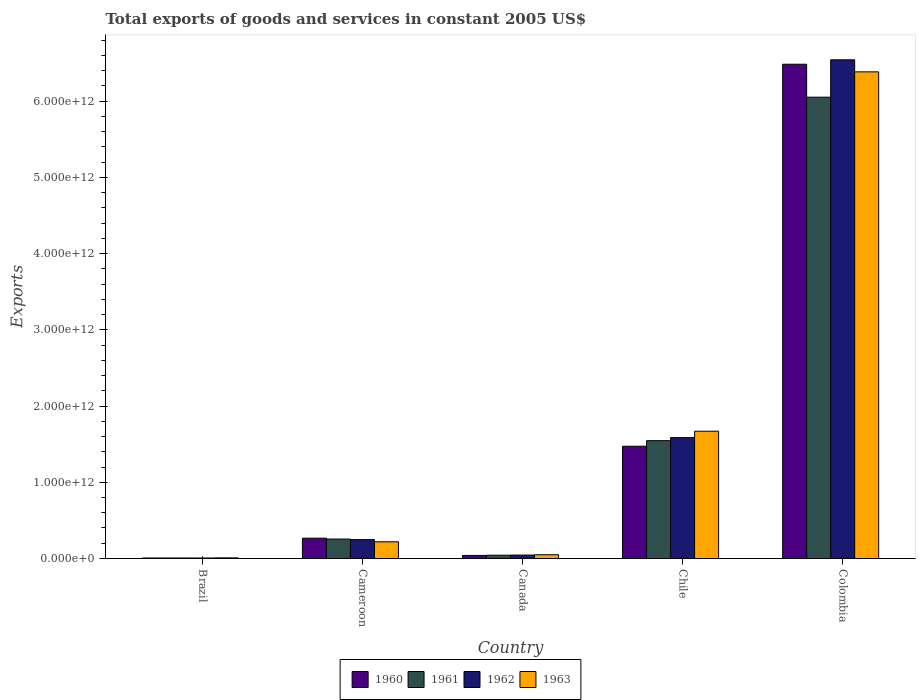How many different coloured bars are there?
Keep it short and to the point. 4. Are the number of bars per tick equal to the number of legend labels?
Ensure brevity in your answer.  Yes. How many bars are there on the 1st tick from the left?
Ensure brevity in your answer.  4. What is the label of the 4th group of bars from the left?
Provide a succinct answer. Chile. What is the total exports of goods and services in 1963 in Canada?
Make the answer very short. 4.91e+1. Across all countries, what is the maximum total exports of goods and services in 1962?
Give a very brief answer. 6.54e+12. Across all countries, what is the minimum total exports of goods and services in 1960?
Provide a short and direct response. 6.63e+09. In which country was the total exports of goods and services in 1963 minimum?
Keep it short and to the point. Brazil. What is the total total exports of goods and services in 1961 in the graph?
Give a very brief answer. 7.90e+12. What is the difference between the total exports of goods and services in 1960 in Cameroon and that in Chile?
Your answer should be compact. -1.21e+12. What is the difference between the total exports of goods and services in 1960 in Brazil and the total exports of goods and services in 1963 in Cameroon?
Provide a short and direct response. -2.12e+11. What is the average total exports of goods and services in 1963 per country?
Your answer should be compact. 1.67e+12. What is the difference between the total exports of goods and services of/in 1962 and total exports of goods and services of/in 1960 in Brazil?
Provide a succinct answer. -1.72e+08. In how many countries, is the total exports of goods and services in 1962 greater than 4000000000000 US$?
Keep it short and to the point. 1. What is the ratio of the total exports of goods and services in 1961 in Brazil to that in Chile?
Offer a terse response. 0. Is the total exports of goods and services in 1960 in Brazil less than that in Canada?
Keep it short and to the point. Yes. What is the difference between the highest and the second highest total exports of goods and services in 1962?
Provide a short and direct response. -6.29e+12. What is the difference between the highest and the lowest total exports of goods and services in 1963?
Offer a very short reply. 6.38e+12. In how many countries, is the total exports of goods and services in 1962 greater than the average total exports of goods and services in 1962 taken over all countries?
Your response must be concise. 1. Is it the case that in every country, the sum of the total exports of goods and services in 1962 and total exports of goods and services in 1963 is greater than the sum of total exports of goods and services in 1960 and total exports of goods and services in 1961?
Offer a very short reply. No. Is it the case that in every country, the sum of the total exports of goods and services in 1960 and total exports of goods and services in 1961 is greater than the total exports of goods and services in 1963?
Your answer should be very brief. Yes. How many bars are there?
Provide a succinct answer. 20. What is the difference between two consecutive major ticks on the Y-axis?
Your response must be concise. 1.00e+12. Are the values on the major ticks of Y-axis written in scientific E-notation?
Ensure brevity in your answer.  Yes. Does the graph contain grids?
Your answer should be compact. No. How many legend labels are there?
Keep it short and to the point. 4. How are the legend labels stacked?
Ensure brevity in your answer.  Horizontal. What is the title of the graph?
Offer a very short reply. Total exports of goods and services in constant 2005 US$. Does "1983" appear as one of the legend labels in the graph?
Your response must be concise. No. What is the label or title of the Y-axis?
Your answer should be very brief. Exports. What is the Exports of 1960 in Brazil?
Give a very brief answer. 6.63e+09. What is the Exports in 1961 in Brazil?
Offer a terse response. 6.97e+09. What is the Exports in 1962 in Brazil?
Offer a terse response. 6.46e+09. What is the Exports of 1963 in Brazil?
Offer a very short reply. 8.26e+09. What is the Exports of 1960 in Cameroon?
Give a very brief answer. 2.66e+11. What is the Exports of 1961 in Cameroon?
Offer a terse response. 2.55e+11. What is the Exports in 1962 in Cameroon?
Provide a succinct answer. 2.48e+11. What is the Exports of 1963 in Cameroon?
Offer a terse response. 2.19e+11. What is the Exports of 1960 in Canada?
Your response must be concise. 4.02e+1. What is the Exports of 1961 in Canada?
Give a very brief answer. 4.29e+1. What is the Exports of 1962 in Canada?
Make the answer very short. 4.49e+1. What is the Exports of 1963 in Canada?
Your answer should be very brief. 4.91e+1. What is the Exports in 1960 in Chile?
Make the answer very short. 1.47e+12. What is the Exports in 1961 in Chile?
Give a very brief answer. 1.55e+12. What is the Exports of 1962 in Chile?
Your response must be concise. 1.59e+12. What is the Exports in 1963 in Chile?
Provide a succinct answer. 1.67e+12. What is the Exports of 1960 in Colombia?
Offer a very short reply. 6.48e+12. What is the Exports in 1961 in Colombia?
Give a very brief answer. 6.05e+12. What is the Exports of 1962 in Colombia?
Offer a terse response. 6.54e+12. What is the Exports of 1963 in Colombia?
Provide a succinct answer. 6.38e+12. Across all countries, what is the maximum Exports in 1960?
Keep it short and to the point. 6.48e+12. Across all countries, what is the maximum Exports in 1961?
Your answer should be very brief. 6.05e+12. Across all countries, what is the maximum Exports in 1962?
Give a very brief answer. 6.54e+12. Across all countries, what is the maximum Exports of 1963?
Offer a terse response. 6.38e+12. Across all countries, what is the minimum Exports of 1960?
Your response must be concise. 6.63e+09. Across all countries, what is the minimum Exports of 1961?
Offer a terse response. 6.97e+09. Across all countries, what is the minimum Exports in 1962?
Your answer should be very brief. 6.46e+09. Across all countries, what is the minimum Exports of 1963?
Make the answer very short. 8.26e+09. What is the total Exports in 1960 in the graph?
Give a very brief answer. 8.27e+12. What is the total Exports of 1961 in the graph?
Your answer should be compact. 7.90e+12. What is the total Exports in 1962 in the graph?
Offer a terse response. 8.43e+12. What is the total Exports in 1963 in the graph?
Ensure brevity in your answer.  8.33e+12. What is the difference between the Exports in 1960 in Brazil and that in Cameroon?
Give a very brief answer. -2.60e+11. What is the difference between the Exports of 1961 in Brazil and that in Cameroon?
Offer a very short reply. -2.48e+11. What is the difference between the Exports in 1962 in Brazil and that in Cameroon?
Give a very brief answer. -2.41e+11. What is the difference between the Exports in 1963 in Brazil and that in Cameroon?
Offer a very short reply. -2.11e+11. What is the difference between the Exports of 1960 in Brazil and that in Canada?
Your response must be concise. -3.36e+1. What is the difference between the Exports of 1961 in Brazil and that in Canada?
Give a very brief answer. -3.60e+1. What is the difference between the Exports in 1962 in Brazil and that in Canada?
Provide a succinct answer. -3.85e+1. What is the difference between the Exports in 1963 in Brazil and that in Canada?
Make the answer very short. -4.08e+1. What is the difference between the Exports in 1960 in Brazil and that in Chile?
Make the answer very short. -1.47e+12. What is the difference between the Exports of 1961 in Brazil and that in Chile?
Offer a very short reply. -1.54e+12. What is the difference between the Exports of 1962 in Brazil and that in Chile?
Give a very brief answer. -1.58e+12. What is the difference between the Exports in 1963 in Brazil and that in Chile?
Ensure brevity in your answer.  -1.66e+12. What is the difference between the Exports of 1960 in Brazil and that in Colombia?
Give a very brief answer. -6.48e+12. What is the difference between the Exports of 1961 in Brazil and that in Colombia?
Keep it short and to the point. -6.04e+12. What is the difference between the Exports in 1962 in Brazil and that in Colombia?
Make the answer very short. -6.54e+12. What is the difference between the Exports in 1963 in Brazil and that in Colombia?
Ensure brevity in your answer.  -6.38e+12. What is the difference between the Exports of 1960 in Cameroon and that in Canada?
Make the answer very short. 2.26e+11. What is the difference between the Exports of 1961 in Cameroon and that in Canada?
Your answer should be very brief. 2.12e+11. What is the difference between the Exports in 1962 in Cameroon and that in Canada?
Make the answer very short. 2.03e+11. What is the difference between the Exports in 1963 in Cameroon and that in Canada?
Keep it short and to the point. 1.70e+11. What is the difference between the Exports in 1960 in Cameroon and that in Chile?
Ensure brevity in your answer.  -1.21e+12. What is the difference between the Exports in 1961 in Cameroon and that in Chile?
Your response must be concise. -1.29e+12. What is the difference between the Exports of 1962 in Cameroon and that in Chile?
Provide a short and direct response. -1.34e+12. What is the difference between the Exports of 1963 in Cameroon and that in Chile?
Offer a terse response. -1.45e+12. What is the difference between the Exports in 1960 in Cameroon and that in Colombia?
Offer a terse response. -6.22e+12. What is the difference between the Exports in 1961 in Cameroon and that in Colombia?
Your response must be concise. -5.80e+12. What is the difference between the Exports in 1962 in Cameroon and that in Colombia?
Give a very brief answer. -6.29e+12. What is the difference between the Exports of 1963 in Cameroon and that in Colombia?
Keep it short and to the point. -6.17e+12. What is the difference between the Exports in 1960 in Canada and that in Chile?
Offer a terse response. -1.43e+12. What is the difference between the Exports of 1961 in Canada and that in Chile?
Offer a terse response. -1.50e+12. What is the difference between the Exports of 1962 in Canada and that in Chile?
Keep it short and to the point. -1.54e+12. What is the difference between the Exports of 1963 in Canada and that in Chile?
Your response must be concise. -1.62e+12. What is the difference between the Exports in 1960 in Canada and that in Colombia?
Offer a very short reply. -6.44e+12. What is the difference between the Exports in 1961 in Canada and that in Colombia?
Offer a terse response. -6.01e+12. What is the difference between the Exports in 1962 in Canada and that in Colombia?
Keep it short and to the point. -6.50e+12. What is the difference between the Exports of 1963 in Canada and that in Colombia?
Your answer should be compact. -6.34e+12. What is the difference between the Exports of 1960 in Chile and that in Colombia?
Your answer should be compact. -5.01e+12. What is the difference between the Exports of 1961 in Chile and that in Colombia?
Your response must be concise. -4.51e+12. What is the difference between the Exports in 1962 in Chile and that in Colombia?
Provide a short and direct response. -4.96e+12. What is the difference between the Exports of 1963 in Chile and that in Colombia?
Ensure brevity in your answer.  -4.71e+12. What is the difference between the Exports of 1960 in Brazil and the Exports of 1961 in Cameroon?
Provide a short and direct response. -2.48e+11. What is the difference between the Exports of 1960 in Brazil and the Exports of 1962 in Cameroon?
Offer a terse response. -2.41e+11. What is the difference between the Exports in 1960 in Brazil and the Exports in 1963 in Cameroon?
Offer a very short reply. -2.12e+11. What is the difference between the Exports in 1961 in Brazil and the Exports in 1962 in Cameroon?
Offer a very short reply. -2.41e+11. What is the difference between the Exports of 1961 in Brazil and the Exports of 1963 in Cameroon?
Keep it short and to the point. -2.12e+11. What is the difference between the Exports of 1962 in Brazil and the Exports of 1963 in Cameroon?
Keep it short and to the point. -2.13e+11. What is the difference between the Exports of 1960 in Brazil and the Exports of 1961 in Canada?
Ensure brevity in your answer.  -3.63e+1. What is the difference between the Exports in 1960 in Brazil and the Exports in 1962 in Canada?
Your response must be concise. -3.83e+1. What is the difference between the Exports in 1960 in Brazil and the Exports in 1963 in Canada?
Your answer should be very brief. -4.24e+1. What is the difference between the Exports in 1961 in Brazil and the Exports in 1962 in Canada?
Keep it short and to the point. -3.79e+1. What is the difference between the Exports of 1961 in Brazil and the Exports of 1963 in Canada?
Provide a succinct answer. -4.21e+1. What is the difference between the Exports of 1962 in Brazil and the Exports of 1963 in Canada?
Keep it short and to the point. -4.26e+1. What is the difference between the Exports in 1960 in Brazil and the Exports in 1961 in Chile?
Offer a very short reply. -1.54e+12. What is the difference between the Exports in 1960 in Brazil and the Exports in 1962 in Chile?
Keep it short and to the point. -1.58e+12. What is the difference between the Exports in 1960 in Brazil and the Exports in 1963 in Chile?
Offer a very short reply. -1.66e+12. What is the difference between the Exports in 1961 in Brazil and the Exports in 1962 in Chile?
Offer a terse response. -1.58e+12. What is the difference between the Exports in 1961 in Brazil and the Exports in 1963 in Chile?
Keep it short and to the point. -1.66e+12. What is the difference between the Exports in 1962 in Brazil and the Exports in 1963 in Chile?
Your response must be concise. -1.66e+12. What is the difference between the Exports in 1960 in Brazil and the Exports in 1961 in Colombia?
Your response must be concise. -6.05e+12. What is the difference between the Exports in 1960 in Brazil and the Exports in 1962 in Colombia?
Offer a very short reply. -6.54e+12. What is the difference between the Exports in 1960 in Brazil and the Exports in 1963 in Colombia?
Provide a short and direct response. -6.38e+12. What is the difference between the Exports of 1961 in Brazil and the Exports of 1962 in Colombia?
Your response must be concise. -6.54e+12. What is the difference between the Exports in 1961 in Brazil and the Exports in 1963 in Colombia?
Offer a terse response. -6.38e+12. What is the difference between the Exports of 1962 in Brazil and the Exports of 1963 in Colombia?
Your answer should be compact. -6.38e+12. What is the difference between the Exports in 1960 in Cameroon and the Exports in 1961 in Canada?
Ensure brevity in your answer.  2.24e+11. What is the difference between the Exports of 1960 in Cameroon and the Exports of 1962 in Canada?
Provide a succinct answer. 2.22e+11. What is the difference between the Exports of 1960 in Cameroon and the Exports of 1963 in Canada?
Offer a very short reply. 2.17e+11. What is the difference between the Exports of 1961 in Cameroon and the Exports of 1962 in Canada?
Your response must be concise. 2.10e+11. What is the difference between the Exports of 1961 in Cameroon and the Exports of 1963 in Canada?
Give a very brief answer. 2.06e+11. What is the difference between the Exports of 1962 in Cameroon and the Exports of 1963 in Canada?
Give a very brief answer. 1.99e+11. What is the difference between the Exports of 1960 in Cameroon and the Exports of 1961 in Chile?
Your answer should be compact. -1.28e+12. What is the difference between the Exports in 1960 in Cameroon and the Exports in 1962 in Chile?
Give a very brief answer. -1.32e+12. What is the difference between the Exports of 1960 in Cameroon and the Exports of 1963 in Chile?
Make the answer very short. -1.40e+12. What is the difference between the Exports in 1961 in Cameroon and the Exports in 1962 in Chile?
Offer a terse response. -1.33e+12. What is the difference between the Exports in 1961 in Cameroon and the Exports in 1963 in Chile?
Keep it short and to the point. -1.41e+12. What is the difference between the Exports of 1962 in Cameroon and the Exports of 1963 in Chile?
Your response must be concise. -1.42e+12. What is the difference between the Exports of 1960 in Cameroon and the Exports of 1961 in Colombia?
Give a very brief answer. -5.79e+12. What is the difference between the Exports in 1960 in Cameroon and the Exports in 1962 in Colombia?
Provide a succinct answer. -6.28e+12. What is the difference between the Exports in 1960 in Cameroon and the Exports in 1963 in Colombia?
Your answer should be very brief. -6.12e+12. What is the difference between the Exports in 1961 in Cameroon and the Exports in 1962 in Colombia?
Your answer should be compact. -6.29e+12. What is the difference between the Exports in 1961 in Cameroon and the Exports in 1963 in Colombia?
Ensure brevity in your answer.  -6.13e+12. What is the difference between the Exports in 1962 in Cameroon and the Exports in 1963 in Colombia?
Offer a terse response. -6.14e+12. What is the difference between the Exports in 1960 in Canada and the Exports in 1961 in Chile?
Provide a short and direct response. -1.51e+12. What is the difference between the Exports of 1960 in Canada and the Exports of 1962 in Chile?
Make the answer very short. -1.55e+12. What is the difference between the Exports in 1960 in Canada and the Exports in 1963 in Chile?
Your answer should be very brief. -1.63e+12. What is the difference between the Exports of 1961 in Canada and the Exports of 1962 in Chile?
Your answer should be compact. -1.54e+12. What is the difference between the Exports of 1961 in Canada and the Exports of 1963 in Chile?
Your answer should be compact. -1.63e+12. What is the difference between the Exports in 1962 in Canada and the Exports in 1963 in Chile?
Offer a terse response. -1.62e+12. What is the difference between the Exports of 1960 in Canada and the Exports of 1961 in Colombia?
Your response must be concise. -6.01e+12. What is the difference between the Exports in 1960 in Canada and the Exports in 1962 in Colombia?
Provide a succinct answer. -6.50e+12. What is the difference between the Exports of 1960 in Canada and the Exports of 1963 in Colombia?
Your response must be concise. -6.34e+12. What is the difference between the Exports in 1961 in Canada and the Exports in 1962 in Colombia?
Provide a succinct answer. -6.50e+12. What is the difference between the Exports in 1961 in Canada and the Exports in 1963 in Colombia?
Give a very brief answer. -6.34e+12. What is the difference between the Exports of 1962 in Canada and the Exports of 1963 in Colombia?
Your answer should be compact. -6.34e+12. What is the difference between the Exports of 1960 in Chile and the Exports of 1961 in Colombia?
Your response must be concise. -4.58e+12. What is the difference between the Exports of 1960 in Chile and the Exports of 1962 in Colombia?
Offer a terse response. -5.07e+12. What is the difference between the Exports of 1960 in Chile and the Exports of 1963 in Colombia?
Provide a short and direct response. -4.91e+12. What is the difference between the Exports in 1961 in Chile and the Exports in 1962 in Colombia?
Provide a succinct answer. -5.00e+12. What is the difference between the Exports in 1961 in Chile and the Exports in 1963 in Colombia?
Make the answer very short. -4.84e+12. What is the difference between the Exports in 1962 in Chile and the Exports in 1963 in Colombia?
Provide a short and direct response. -4.80e+12. What is the average Exports in 1960 per country?
Your response must be concise. 1.65e+12. What is the average Exports of 1961 per country?
Provide a short and direct response. 1.58e+12. What is the average Exports of 1962 per country?
Provide a succinct answer. 1.69e+12. What is the average Exports in 1963 per country?
Your answer should be very brief. 1.67e+12. What is the difference between the Exports of 1960 and Exports of 1961 in Brazil?
Ensure brevity in your answer.  -3.44e+08. What is the difference between the Exports in 1960 and Exports in 1962 in Brazil?
Offer a very short reply. 1.72e+08. What is the difference between the Exports in 1960 and Exports in 1963 in Brazil?
Keep it short and to the point. -1.64e+09. What is the difference between the Exports of 1961 and Exports of 1962 in Brazil?
Provide a short and direct response. 5.16e+08. What is the difference between the Exports of 1961 and Exports of 1963 in Brazil?
Offer a very short reply. -1.29e+09. What is the difference between the Exports of 1962 and Exports of 1963 in Brazil?
Your answer should be compact. -1.81e+09. What is the difference between the Exports in 1960 and Exports in 1961 in Cameroon?
Offer a very short reply. 1.14e+1. What is the difference between the Exports in 1960 and Exports in 1962 in Cameroon?
Your answer should be very brief. 1.88e+1. What is the difference between the Exports of 1960 and Exports of 1963 in Cameroon?
Provide a succinct answer. 4.75e+1. What is the difference between the Exports in 1961 and Exports in 1962 in Cameroon?
Ensure brevity in your answer.  7.43e+09. What is the difference between the Exports in 1961 and Exports in 1963 in Cameroon?
Make the answer very short. 3.61e+1. What is the difference between the Exports in 1962 and Exports in 1963 in Cameroon?
Make the answer very short. 2.87e+1. What is the difference between the Exports of 1960 and Exports of 1961 in Canada?
Provide a succinct answer. -2.73e+09. What is the difference between the Exports of 1960 and Exports of 1962 in Canada?
Make the answer very short. -4.72e+09. What is the difference between the Exports of 1960 and Exports of 1963 in Canada?
Provide a short and direct response. -8.86e+09. What is the difference between the Exports of 1961 and Exports of 1962 in Canada?
Ensure brevity in your answer.  -1.98e+09. What is the difference between the Exports in 1961 and Exports in 1963 in Canada?
Give a very brief answer. -6.12e+09. What is the difference between the Exports of 1962 and Exports of 1963 in Canada?
Offer a very short reply. -4.14e+09. What is the difference between the Exports of 1960 and Exports of 1961 in Chile?
Ensure brevity in your answer.  -7.28e+1. What is the difference between the Exports in 1960 and Exports in 1962 in Chile?
Make the answer very short. -1.13e+11. What is the difference between the Exports of 1960 and Exports of 1963 in Chile?
Offer a terse response. -1.97e+11. What is the difference between the Exports in 1961 and Exports in 1962 in Chile?
Give a very brief answer. -4.03e+1. What is the difference between the Exports in 1961 and Exports in 1963 in Chile?
Keep it short and to the point. -1.24e+11. What is the difference between the Exports of 1962 and Exports of 1963 in Chile?
Provide a succinct answer. -8.37e+1. What is the difference between the Exports in 1960 and Exports in 1961 in Colombia?
Your response must be concise. 4.32e+11. What is the difference between the Exports of 1960 and Exports of 1962 in Colombia?
Make the answer very short. -5.79e+1. What is the difference between the Exports in 1960 and Exports in 1963 in Colombia?
Make the answer very short. 1.00e+11. What is the difference between the Exports of 1961 and Exports of 1962 in Colombia?
Provide a succinct answer. -4.90e+11. What is the difference between the Exports of 1961 and Exports of 1963 in Colombia?
Provide a succinct answer. -3.32e+11. What is the difference between the Exports of 1962 and Exports of 1963 in Colombia?
Your answer should be compact. 1.58e+11. What is the ratio of the Exports of 1960 in Brazil to that in Cameroon?
Offer a very short reply. 0.02. What is the ratio of the Exports of 1961 in Brazil to that in Cameroon?
Your answer should be very brief. 0.03. What is the ratio of the Exports of 1962 in Brazil to that in Cameroon?
Provide a short and direct response. 0.03. What is the ratio of the Exports in 1963 in Brazil to that in Cameroon?
Offer a very short reply. 0.04. What is the ratio of the Exports in 1960 in Brazil to that in Canada?
Provide a short and direct response. 0.16. What is the ratio of the Exports in 1961 in Brazil to that in Canada?
Keep it short and to the point. 0.16. What is the ratio of the Exports of 1962 in Brazil to that in Canada?
Ensure brevity in your answer.  0.14. What is the ratio of the Exports of 1963 in Brazil to that in Canada?
Your response must be concise. 0.17. What is the ratio of the Exports in 1960 in Brazil to that in Chile?
Offer a very short reply. 0. What is the ratio of the Exports of 1961 in Brazil to that in Chile?
Offer a very short reply. 0. What is the ratio of the Exports in 1962 in Brazil to that in Chile?
Your answer should be compact. 0. What is the ratio of the Exports of 1963 in Brazil to that in Chile?
Give a very brief answer. 0. What is the ratio of the Exports in 1961 in Brazil to that in Colombia?
Offer a very short reply. 0. What is the ratio of the Exports of 1963 in Brazil to that in Colombia?
Provide a succinct answer. 0. What is the ratio of the Exports in 1960 in Cameroon to that in Canada?
Your answer should be very brief. 6.63. What is the ratio of the Exports in 1961 in Cameroon to that in Canada?
Provide a short and direct response. 5.94. What is the ratio of the Exports of 1962 in Cameroon to that in Canada?
Offer a terse response. 5.51. What is the ratio of the Exports of 1963 in Cameroon to that in Canada?
Keep it short and to the point. 4.46. What is the ratio of the Exports in 1960 in Cameroon to that in Chile?
Your answer should be very brief. 0.18. What is the ratio of the Exports in 1961 in Cameroon to that in Chile?
Provide a succinct answer. 0.17. What is the ratio of the Exports of 1962 in Cameroon to that in Chile?
Give a very brief answer. 0.16. What is the ratio of the Exports of 1963 in Cameroon to that in Chile?
Make the answer very short. 0.13. What is the ratio of the Exports in 1960 in Cameroon to that in Colombia?
Your answer should be compact. 0.04. What is the ratio of the Exports of 1961 in Cameroon to that in Colombia?
Offer a terse response. 0.04. What is the ratio of the Exports of 1962 in Cameroon to that in Colombia?
Offer a very short reply. 0.04. What is the ratio of the Exports of 1963 in Cameroon to that in Colombia?
Your response must be concise. 0.03. What is the ratio of the Exports in 1960 in Canada to that in Chile?
Give a very brief answer. 0.03. What is the ratio of the Exports of 1961 in Canada to that in Chile?
Ensure brevity in your answer.  0.03. What is the ratio of the Exports in 1962 in Canada to that in Chile?
Provide a succinct answer. 0.03. What is the ratio of the Exports in 1963 in Canada to that in Chile?
Your response must be concise. 0.03. What is the ratio of the Exports in 1960 in Canada to that in Colombia?
Provide a short and direct response. 0.01. What is the ratio of the Exports in 1961 in Canada to that in Colombia?
Provide a succinct answer. 0.01. What is the ratio of the Exports in 1962 in Canada to that in Colombia?
Ensure brevity in your answer.  0.01. What is the ratio of the Exports of 1963 in Canada to that in Colombia?
Your response must be concise. 0.01. What is the ratio of the Exports of 1960 in Chile to that in Colombia?
Offer a very short reply. 0.23. What is the ratio of the Exports of 1961 in Chile to that in Colombia?
Your answer should be compact. 0.26. What is the ratio of the Exports of 1962 in Chile to that in Colombia?
Your response must be concise. 0.24. What is the ratio of the Exports of 1963 in Chile to that in Colombia?
Provide a succinct answer. 0.26. What is the difference between the highest and the second highest Exports in 1960?
Offer a very short reply. 5.01e+12. What is the difference between the highest and the second highest Exports in 1961?
Your answer should be compact. 4.51e+12. What is the difference between the highest and the second highest Exports in 1962?
Provide a short and direct response. 4.96e+12. What is the difference between the highest and the second highest Exports in 1963?
Make the answer very short. 4.71e+12. What is the difference between the highest and the lowest Exports in 1960?
Your answer should be compact. 6.48e+12. What is the difference between the highest and the lowest Exports of 1961?
Keep it short and to the point. 6.04e+12. What is the difference between the highest and the lowest Exports of 1962?
Offer a very short reply. 6.54e+12. What is the difference between the highest and the lowest Exports in 1963?
Give a very brief answer. 6.38e+12. 